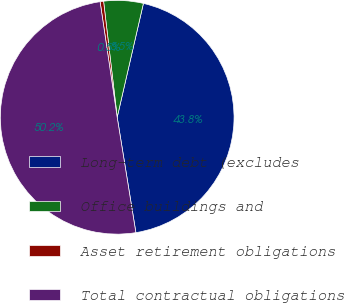Convert chart. <chart><loc_0><loc_0><loc_500><loc_500><pie_chart><fcel>Long-term debt (excludes<fcel>Office buildings and<fcel>Asset retirement obligations<fcel>Total contractual obligations<nl><fcel>43.84%<fcel>5.46%<fcel>0.48%<fcel>50.22%<nl></chart> 